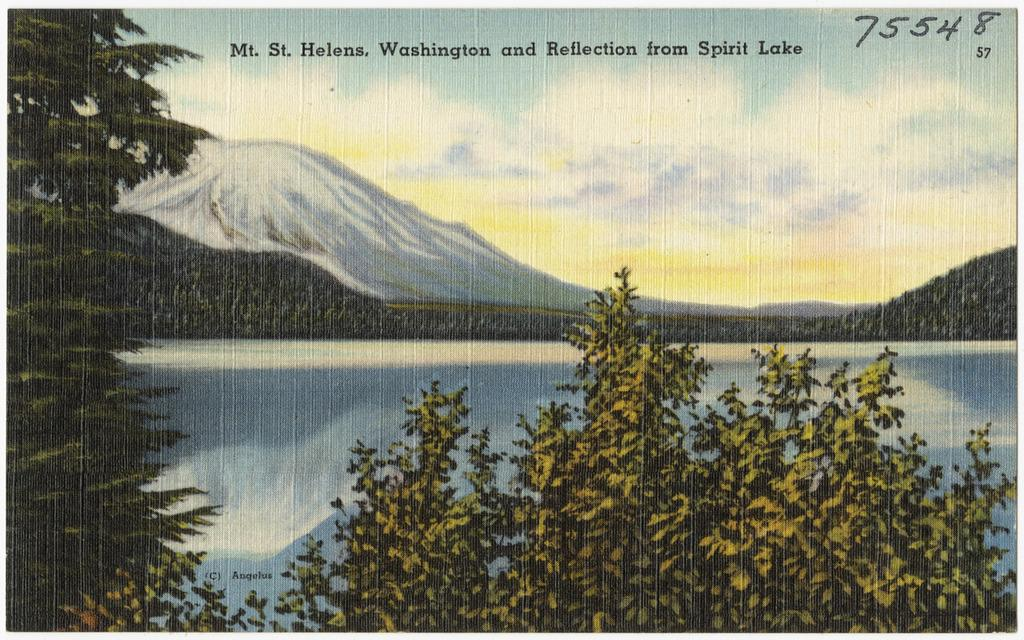What type of vegetation is at the front of the image? There are trees at the front of the image. What is located at the center of the image? There is water at the center of the image. What can be seen in the background of the image? There are mountains in the background of the image. What is visible at the top of the image? The sky is visible at the top of the image. Can you tell me how many flocks of birds are flying over the mountains in the image? There is no mention of birds or flocks in the image; it features trees, water, mountains, and the sky. Is there a volcano visible in the image? There is no volcano present in the image; it features trees, water, mountains, and the sky. 